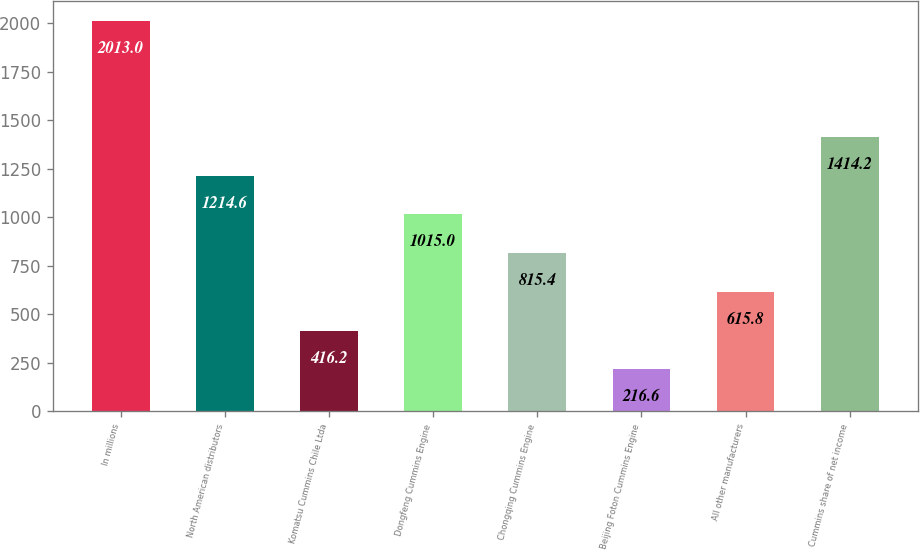Convert chart. <chart><loc_0><loc_0><loc_500><loc_500><bar_chart><fcel>In millions<fcel>North American distributors<fcel>Komatsu Cummins Chile Ltda<fcel>Dongfeng Cummins Engine<fcel>Chongqing Cummins Engine<fcel>Beijing Foton Cummins Engine<fcel>All other manufacturers<fcel>Cummins share of net income<nl><fcel>2013<fcel>1214.6<fcel>416.2<fcel>1015<fcel>815.4<fcel>216.6<fcel>615.8<fcel>1414.2<nl></chart> 